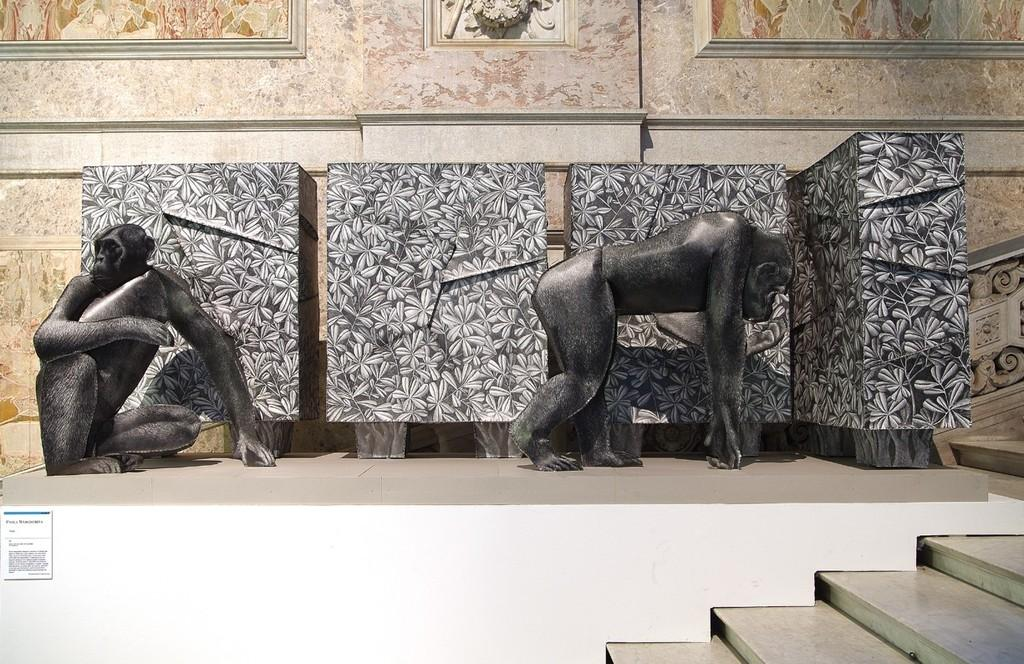What is located in front of the image? There are steps in front of the image. What can be seen in the middle of the image? In the middle of the image, there are sculptures of two monkeys. What can be observed in the background of the image? There are designs on the walls in the background of the image. What type of pleasure can be seen being enjoyed by the crowd in the image? There is no crowd present in the image, so it is not possible to determine what type of pleasure might be enjoyed. 